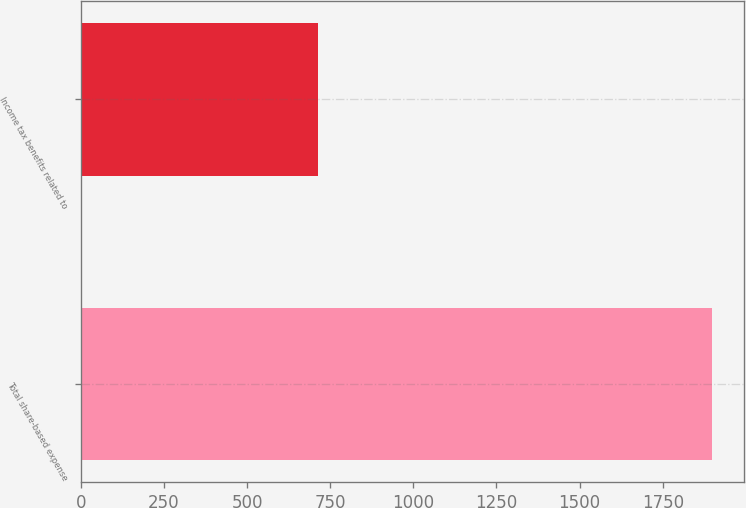Convert chart. <chart><loc_0><loc_0><loc_500><loc_500><bar_chart><fcel>Total share-based expense<fcel>Income tax benefits related to<nl><fcel>1899<fcel>713<nl></chart> 